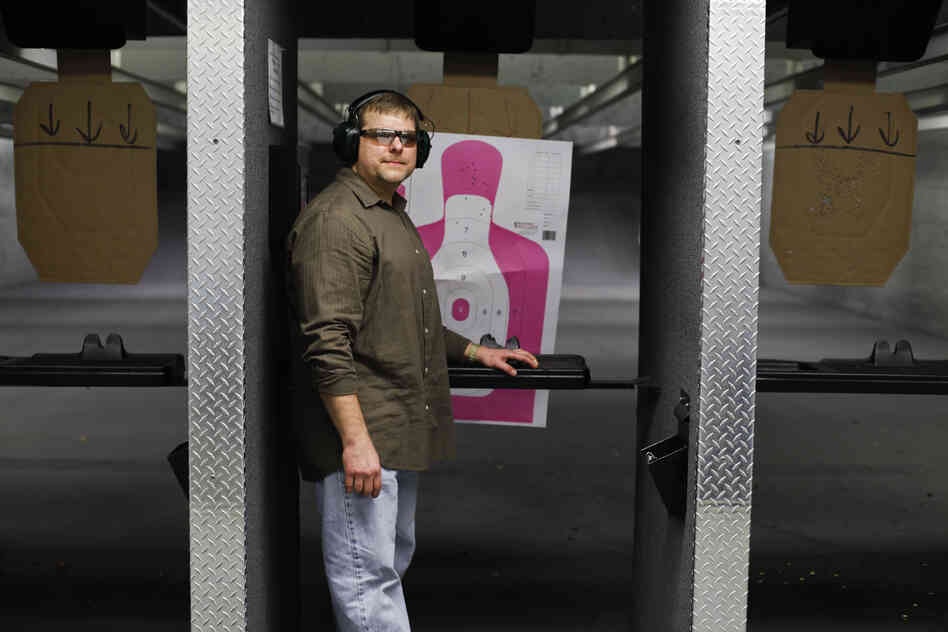What other facilities might complement this shooting range for a comprehensive training facility? To create a comprehensive training facility, several additional features could be included alongside the shooting range. Firstly, a simulated urban environment would allow for realistic scenario-based training, where users can practice tactical movements and strategies in a controlled setting.

A gym equipped with strength and conditioning equipment would support physical fitness and endurance, essential for effective shooting and maneuvering. Classroom spaces for theoretical instruction and strategy discussions could enhance learning, covering topics such as firearm maintenance, safety protocols, and tactical planning.

Furthermore, incorporating an obstacle course would challenge users' agility and coordination, complementing their shooting skills. Adding a virtual reality training room could provide immersive, versatile training simulations, adapting to various skill levels and scenarios. Together, these facilities would create a well-rounded training environment, fostering comprehensive skill development. 